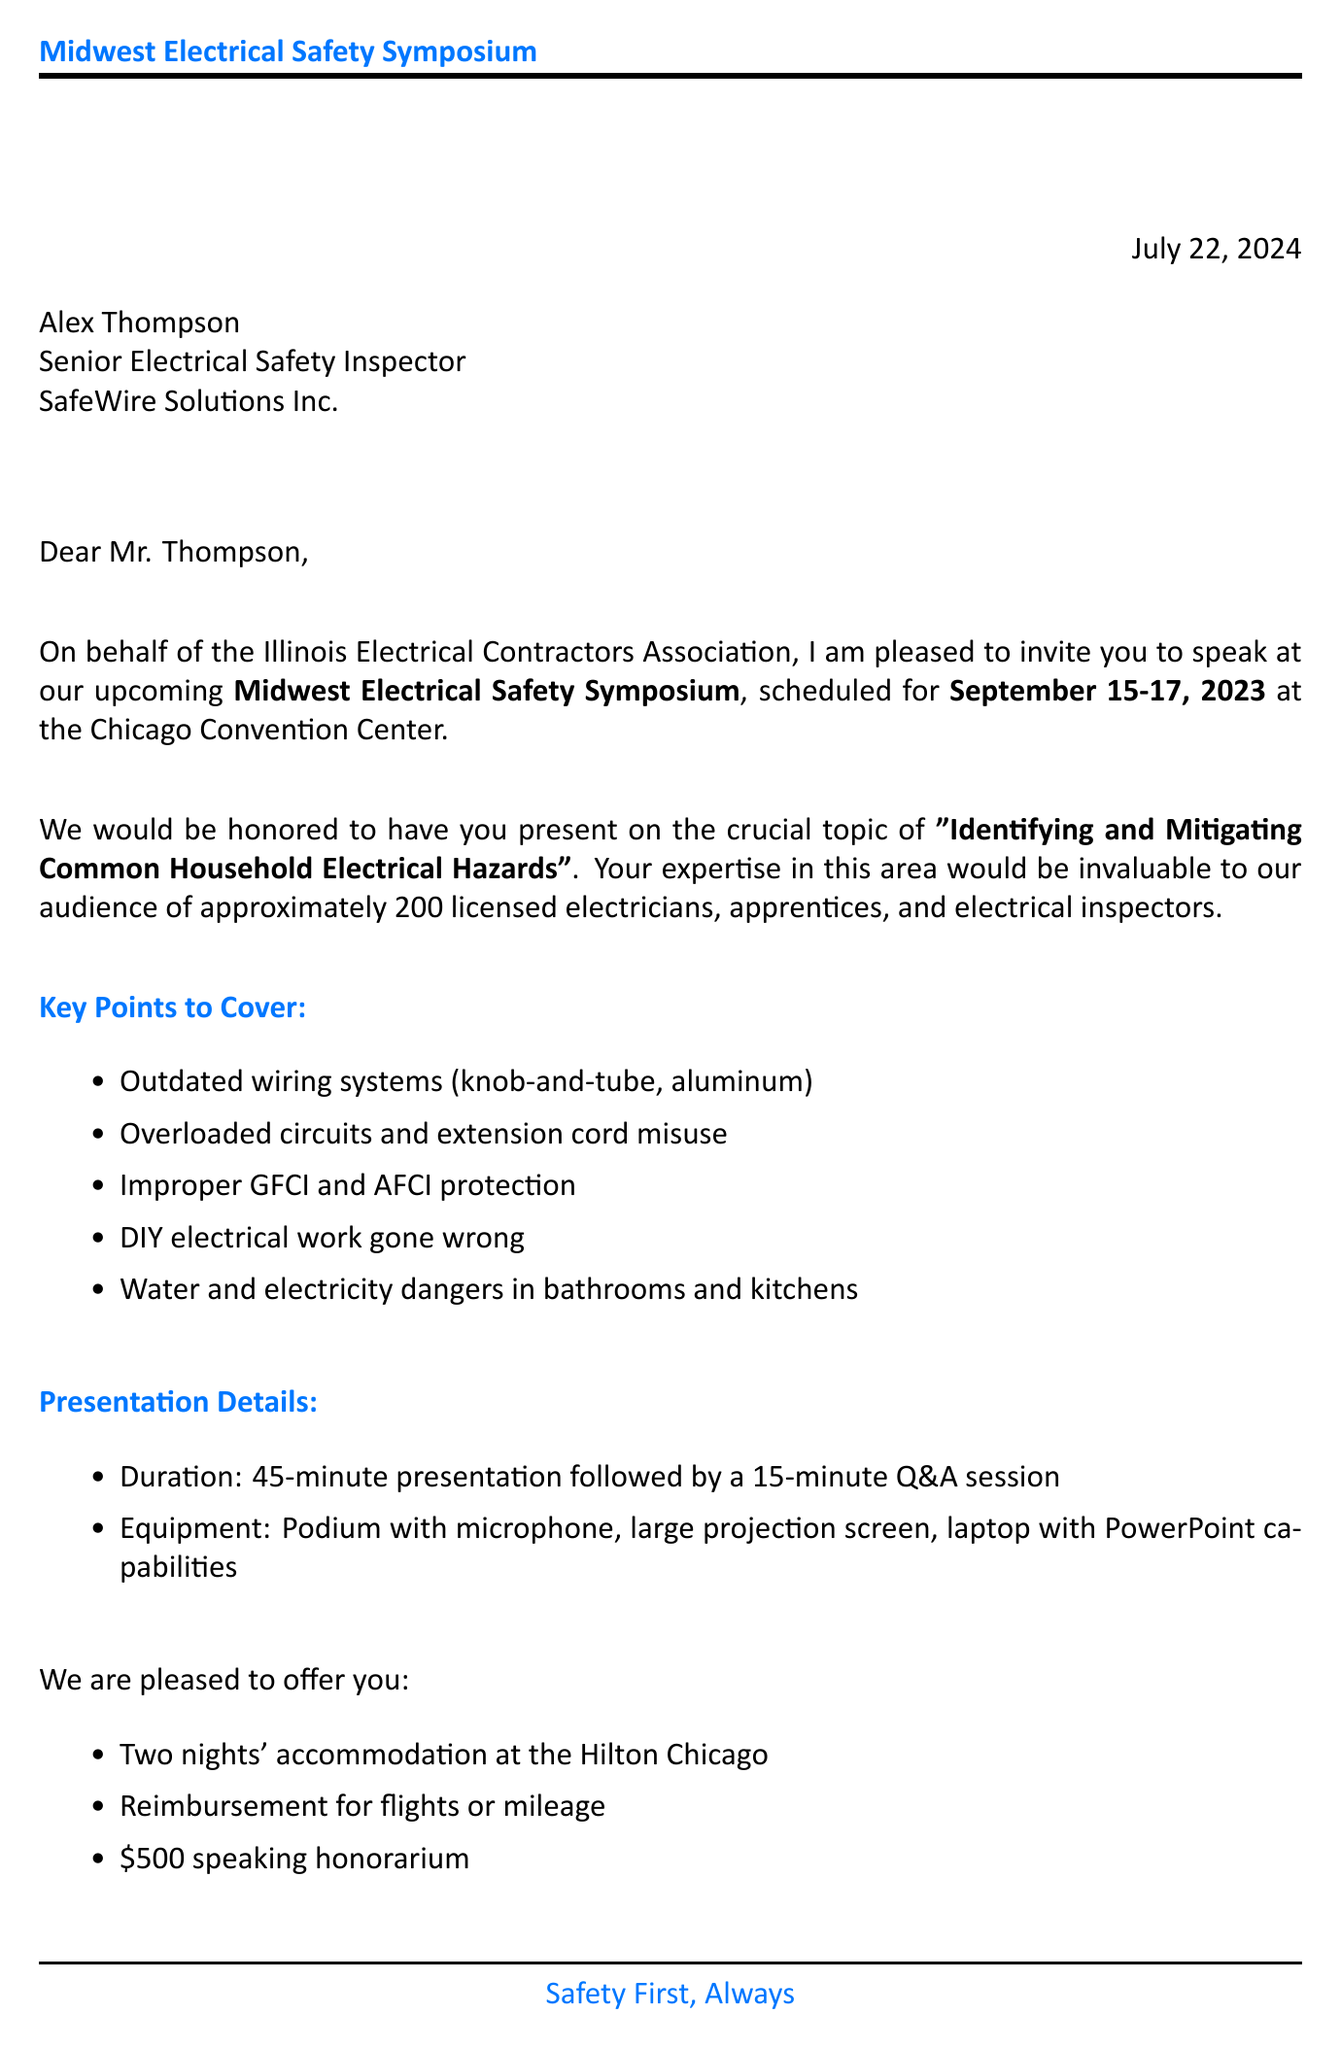What is the name of the conference? The name of the conference is mentioned in the letter, which is the Midwest Electrical Safety Symposium.
Answer: Midwest Electrical Safety Symposium Who is the speaker invited to the conference? The letter specifies the speaker's name, which is Alex Thompson.
Answer: Alex Thompson What is the date of the event? The date of the event is clearly stated in the document as September 15-17, 2023.
Answer: September 15-17, 2023 How long is the presentation scheduled for? The letter provides the duration of the presentation, which is 45 minutes.
Answer: 45 minutes What topic will the speaker address? The topic of the presentation is listed in the invitation as "Identifying and Mitigating Common Household Electrical Hazards."
Answer: Identifying and Mitigating Common Household Electrical Hazards What is the honorarium offered to the speaker? The honorarium for speaking at the event is specifically mentioned as $500.
Answer: $500 How many people are expected to attend the conference? The audience size is approximately 200 attendees, as stated in the letter.
Answer: Approximately 200 attendees What is the deadline for confirming participation? The document indicates the deadline for response, which is June 30, 2023.
Answer: June 30, 2023 What is the name of the contact person for the event? The letter identifies the conference coordinator's name as Sarah Martinez.
Answer: Sarah Martinez 